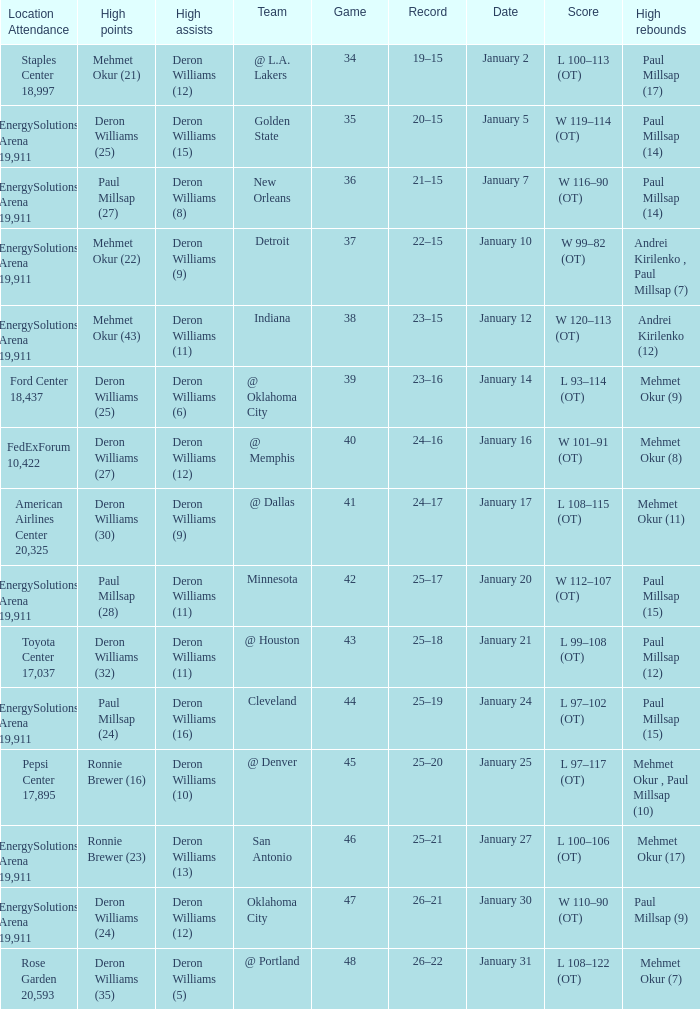What was the score of Game 48? L 108–122 (OT). 